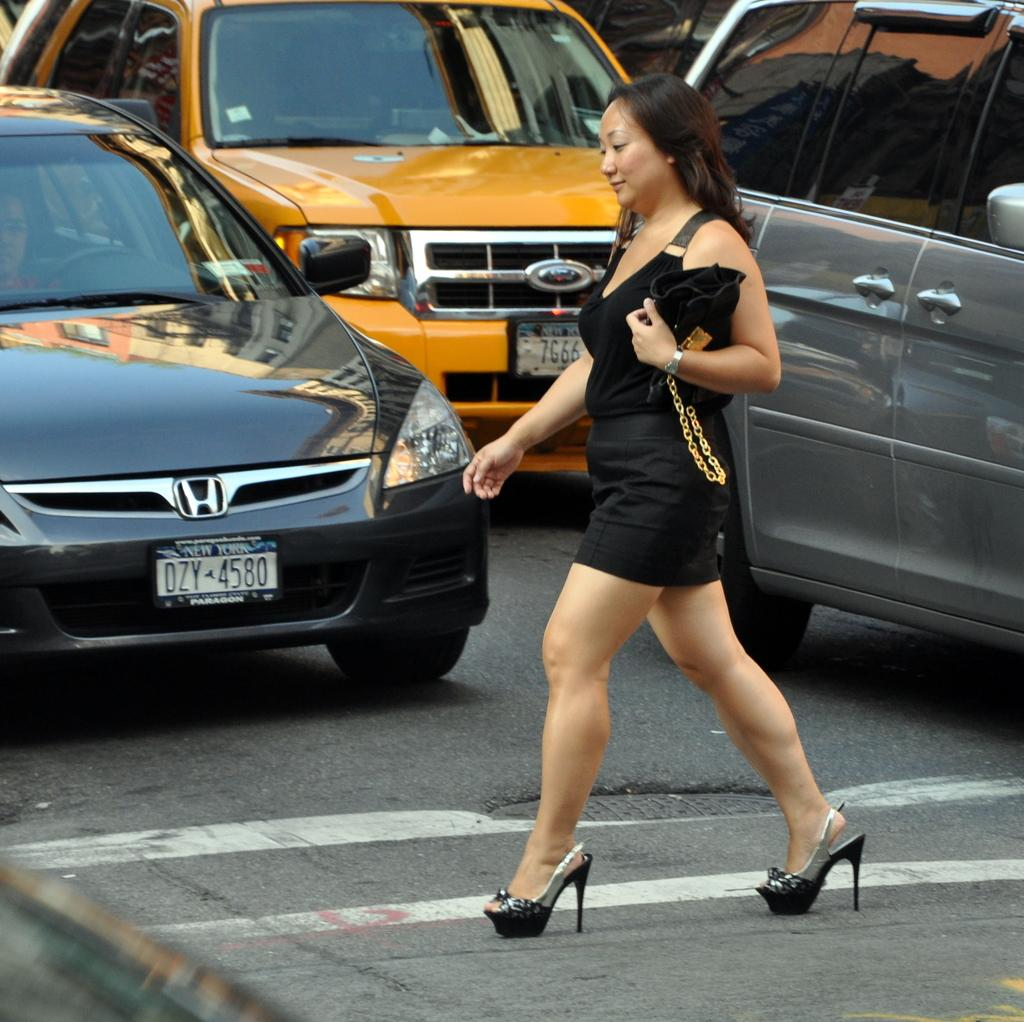<image>
Offer a succinct explanation of the picture presented. A woman crosses the street in front of a car with New York plates. 